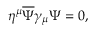<formula> <loc_0><loc_0><loc_500><loc_500>\eta ^ { \mu } { \overline { \Psi } } \gamma _ { \mu } \Psi = 0 ,</formula> 